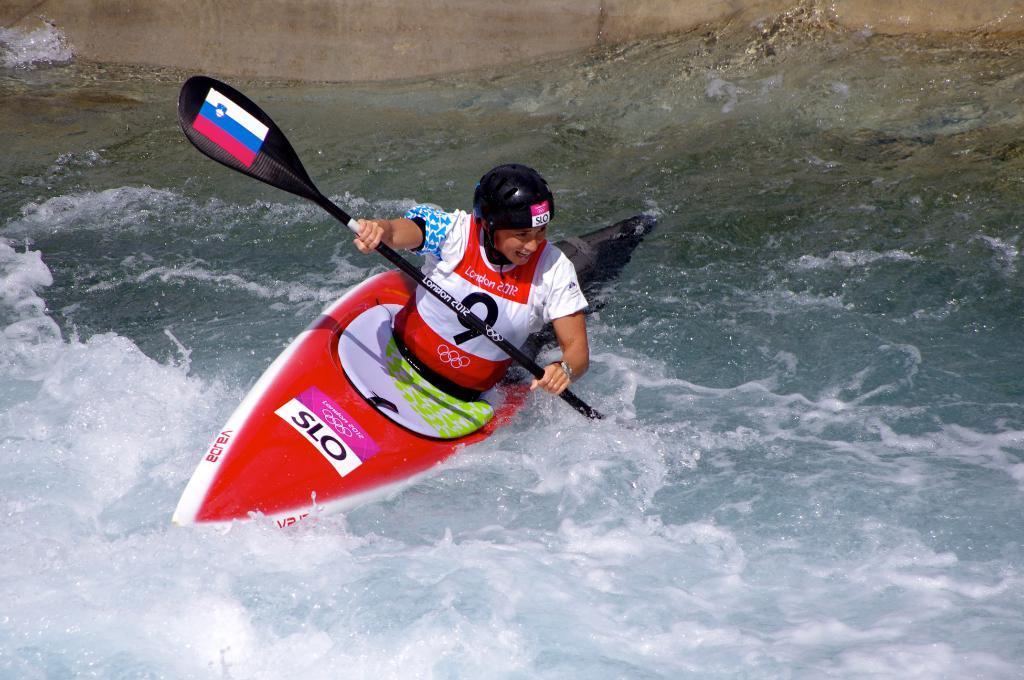Can you describe this image briefly? There is a woman kayaking in the water in the foreground area of the image holding a paddle in her hands, it seems like a wall in the background. 